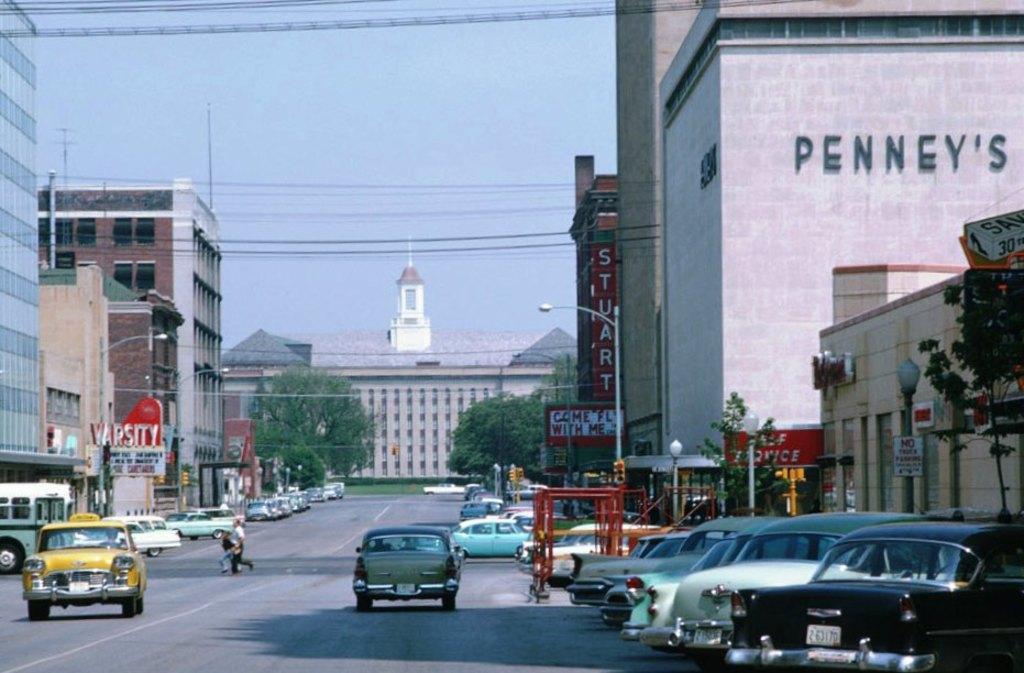<image>
Relay a brief, clear account of the picture shown. A downtown area in times past with old cars and an old Penney's building. 